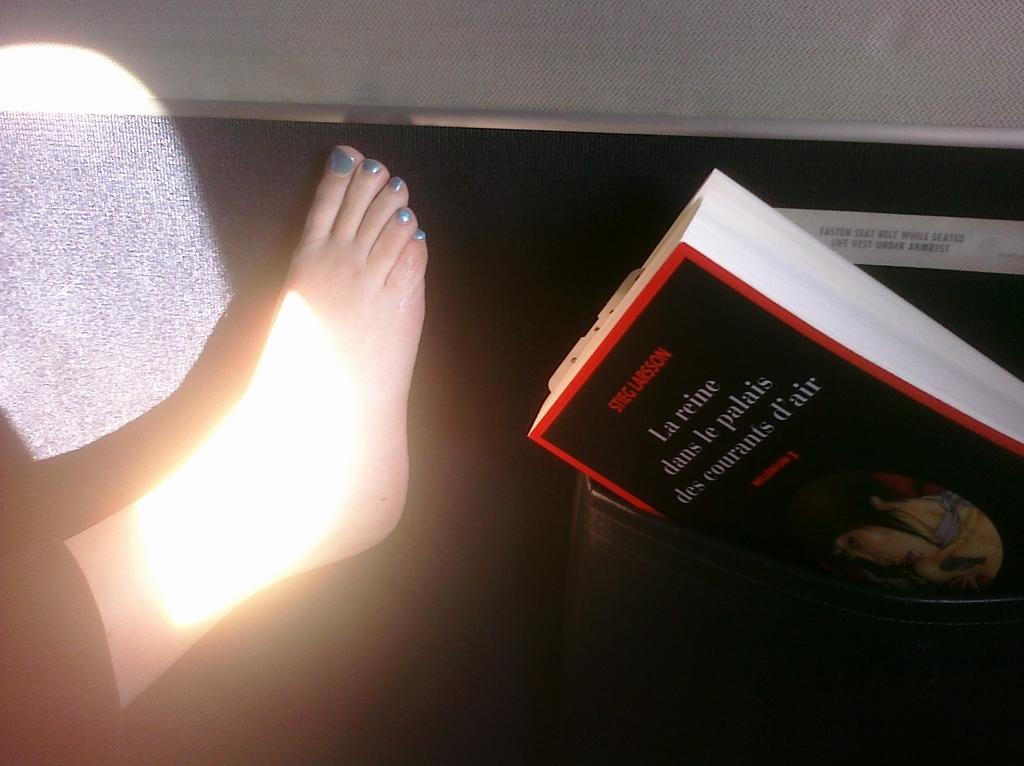Provide a one-sentence caption for the provided image. A foot next to the book La reine dans le palais des courants d'air. 